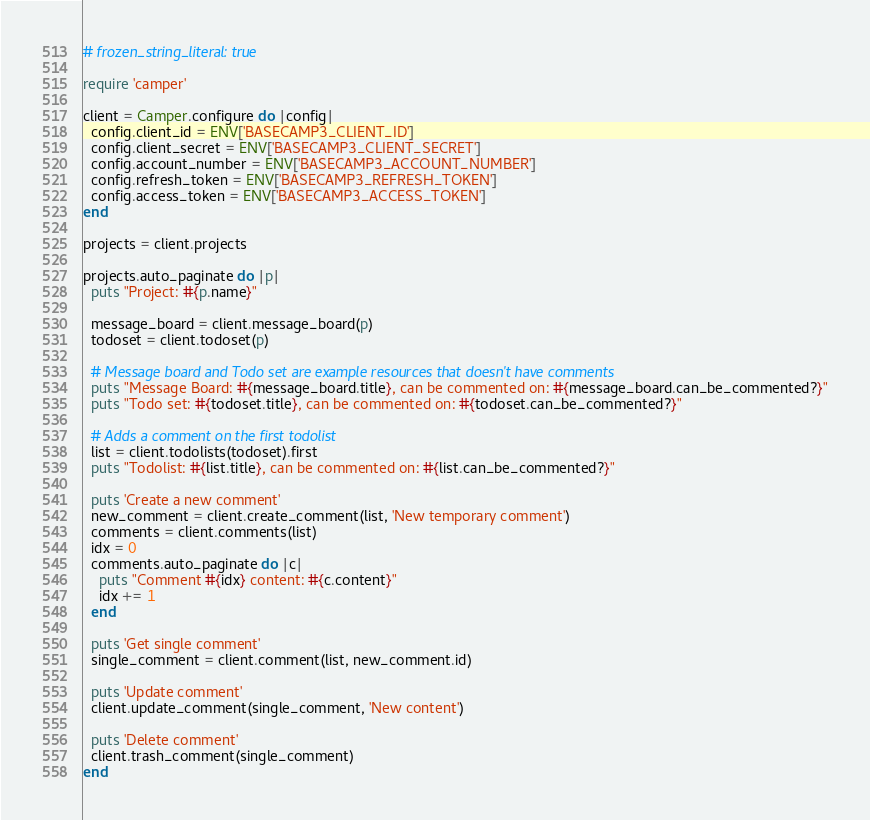<code> <loc_0><loc_0><loc_500><loc_500><_Ruby_># frozen_string_literal: true

require 'camper'

client = Camper.configure do |config|
  config.client_id = ENV['BASECAMP3_CLIENT_ID']
  config.client_secret = ENV['BASECAMP3_CLIENT_SECRET']
  config.account_number = ENV['BASECAMP3_ACCOUNT_NUMBER']
  config.refresh_token = ENV['BASECAMP3_REFRESH_TOKEN']
  config.access_token = ENV['BASECAMP3_ACCESS_TOKEN']
end

projects = client.projects

projects.auto_paginate do |p|
  puts "Project: #{p.name}"

  message_board = client.message_board(p)
  todoset = client.todoset(p)

  # Message board and Todo set are example resources that doesn't have comments
  puts "Message Board: #{message_board.title}, can be commented on: #{message_board.can_be_commented?}"
  puts "Todo set: #{todoset.title}, can be commented on: #{todoset.can_be_commented?}"

  # Adds a comment on the first todolist
  list = client.todolists(todoset).first
  puts "Todolist: #{list.title}, can be commented on: #{list.can_be_commented?}"

  puts 'Create a new comment'
  new_comment = client.create_comment(list, 'New temporary comment')
  comments = client.comments(list)
  idx = 0
  comments.auto_paginate do |c|
    puts "Comment #{idx} content: #{c.content}"
    idx += 1
  end

  puts 'Get single comment'
  single_comment = client.comment(list, new_comment.id)

  puts 'Update comment'
  client.update_comment(single_comment, 'New content')

  puts 'Delete comment'
  client.trash_comment(single_comment)
end
</code> 